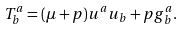<formula> <loc_0><loc_0><loc_500><loc_500>T ^ { a } _ { b } = ( \mu + p ) u ^ { a } u _ { b } + p g ^ { a } _ { b } .</formula> 